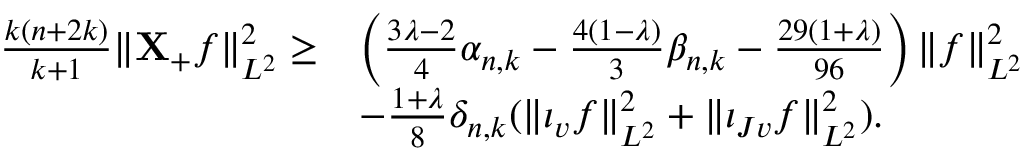<formula> <loc_0><loc_0><loc_500><loc_500>\begin{array} { r l } { \frac { k ( n + 2 k ) } { k + 1 } \| X _ { + } f \| _ { L ^ { 2 } } ^ { 2 } \geq } & { \left ( \frac { 3 \lambda - 2 } { 4 } \alpha _ { n , k } - \frac { 4 ( 1 - \lambda ) } { 3 } \beta _ { n , k } - \frac { 2 9 ( 1 + \lambda ) } { 9 6 } \right ) \| f \| _ { L ^ { 2 } } ^ { 2 } } \\ & { - \frac { 1 + \lambda } { 8 } \delta _ { n , k } ( \| \iota _ { v } f \| _ { L ^ { 2 } } ^ { 2 } + \| \iota _ { J v } f \| _ { L ^ { 2 } } ^ { 2 } ) . } \end{array}</formula> 